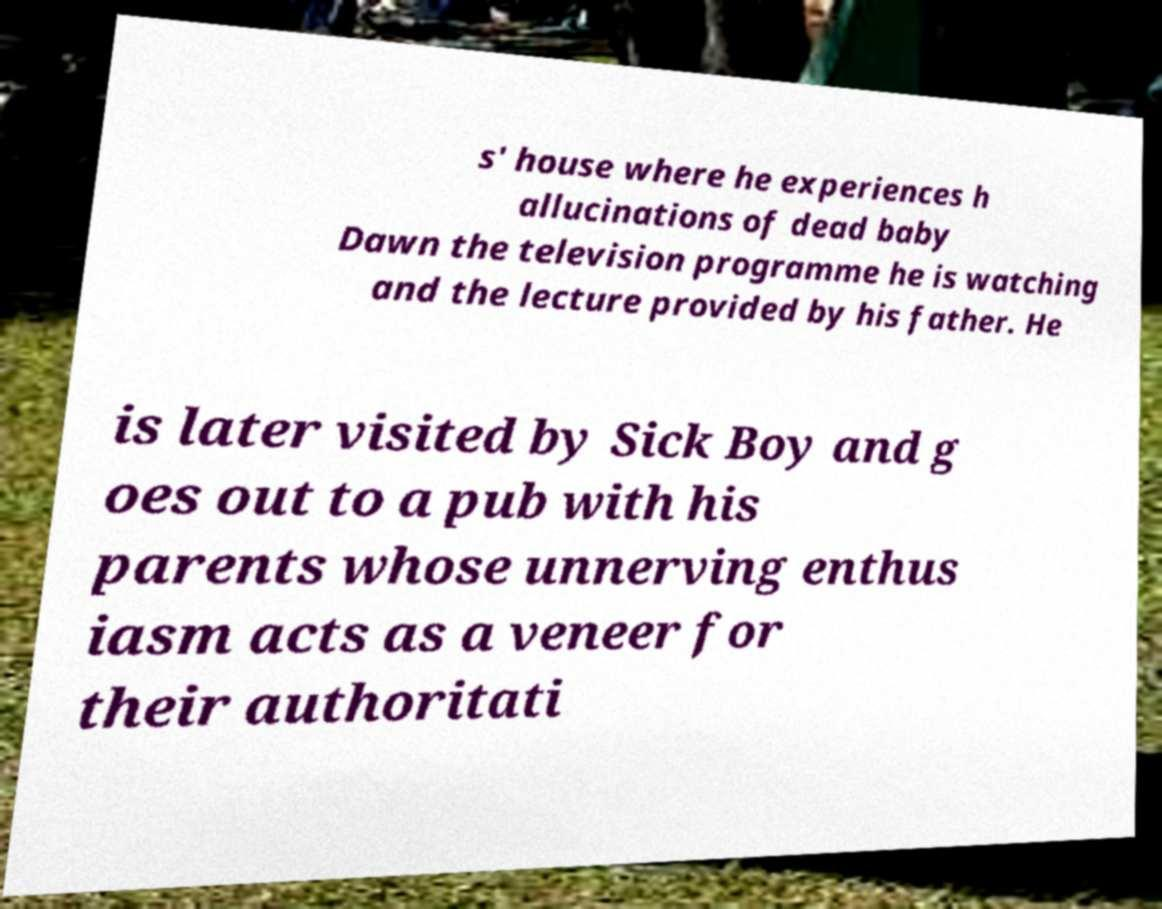I need the written content from this picture converted into text. Can you do that? s' house where he experiences h allucinations of dead baby Dawn the television programme he is watching and the lecture provided by his father. He is later visited by Sick Boy and g oes out to a pub with his parents whose unnerving enthus iasm acts as a veneer for their authoritati 